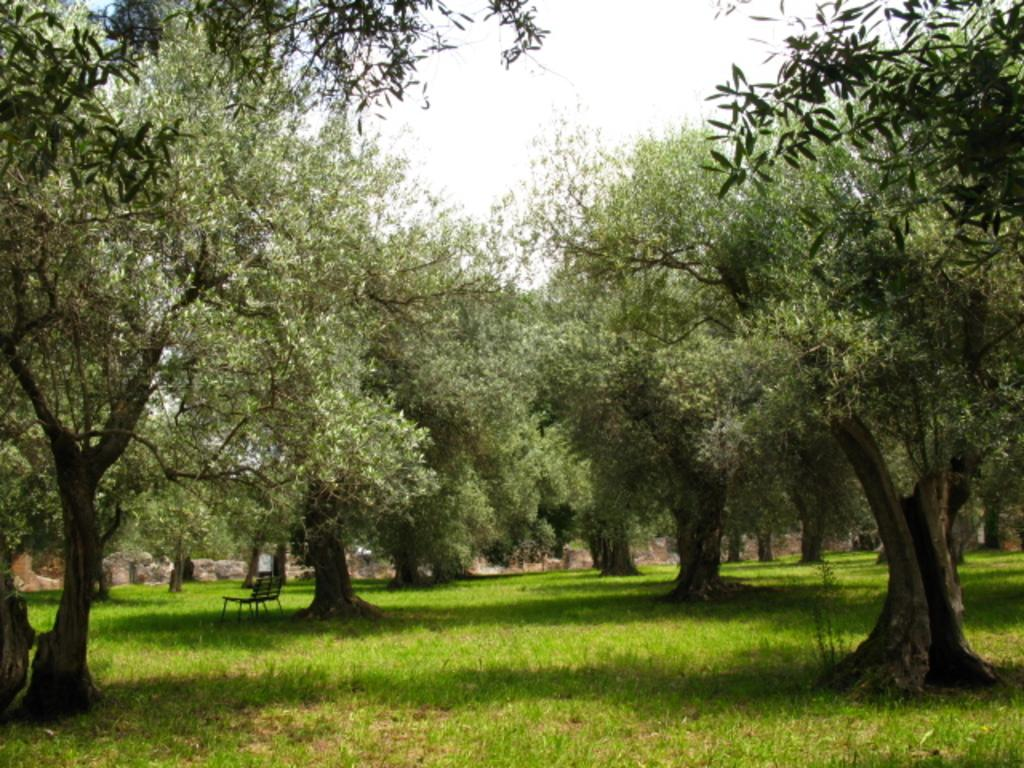What type of landscape is depicted in the image? The image features a grass lawn. What other natural elements can be seen in the image? There are many huge trees in the image. What type of yam is being used in the competition in the image? There is no competition or yam present in the image; it features a grass lawn and huge trees. 